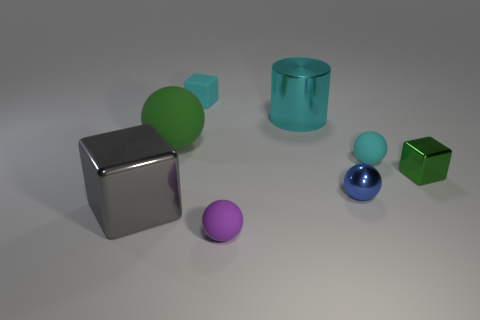What material is the cube that is the same color as the cylinder?
Ensure brevity in your answer.  Rubber. What is the size of the sphere that is the same color as the large cylinder?
Offer a terse response. Small. There is another blue object that is the same shape as the large rubber thing; what material is it?
Ensure brevity in your answer.  Metal. Does the metal cylinder have the same color as the tiny matte cube?
Provide a short and direct response. Yes. There is a tiny thing that is in front of the big block; is there a small cyan matte object that is to the right of it?
Your response must be concise. Yes. There is a block behind the green metallic thing; does it have the same size as the shiny block to the right of the cyan metal cylinder?
Your answer should be compact. Yes. How many tiny objects are purple shiny blocks or blue metallic objects?
Give a very brief answer. 1. There is a block to the right of the small matte object that is to the left of the tiny purple object; what is it made of?
Offer a very short reply. Metal. What shape is the tiny object that is the same color as the rubber block?
Provide a short and direct response. Sphere. Is there a large brown block made of the same material as the large gray block?
Give a very brief answer. No. 